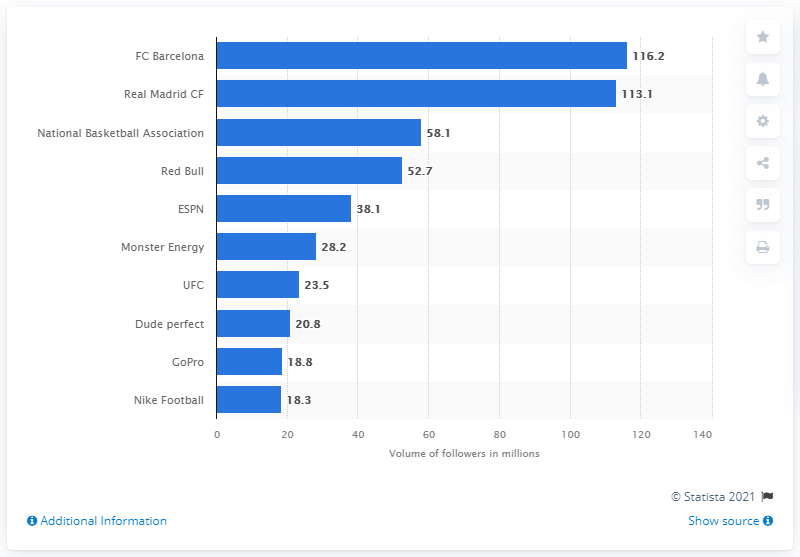Highlight a few significant elements in this photo. Red Bull is widely recognized as one of the most well-known and popular energy drinks in the world. 